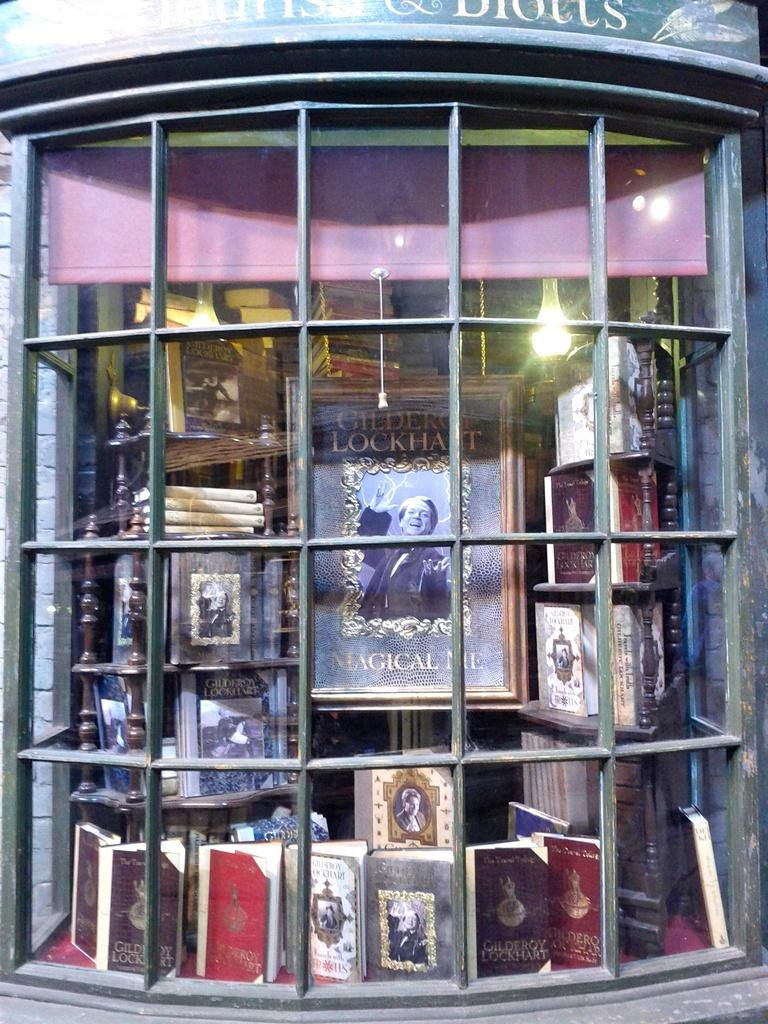What type of object is in the foreground of the image? There is a metal grill in the foreground of the image. What can be seen in the background of the image? There are books and a photo frame in the background of the image. How many bushes are visible in the image? There are no bushes present in the image. What type of list is being used in the image? There is no list present in the image. 